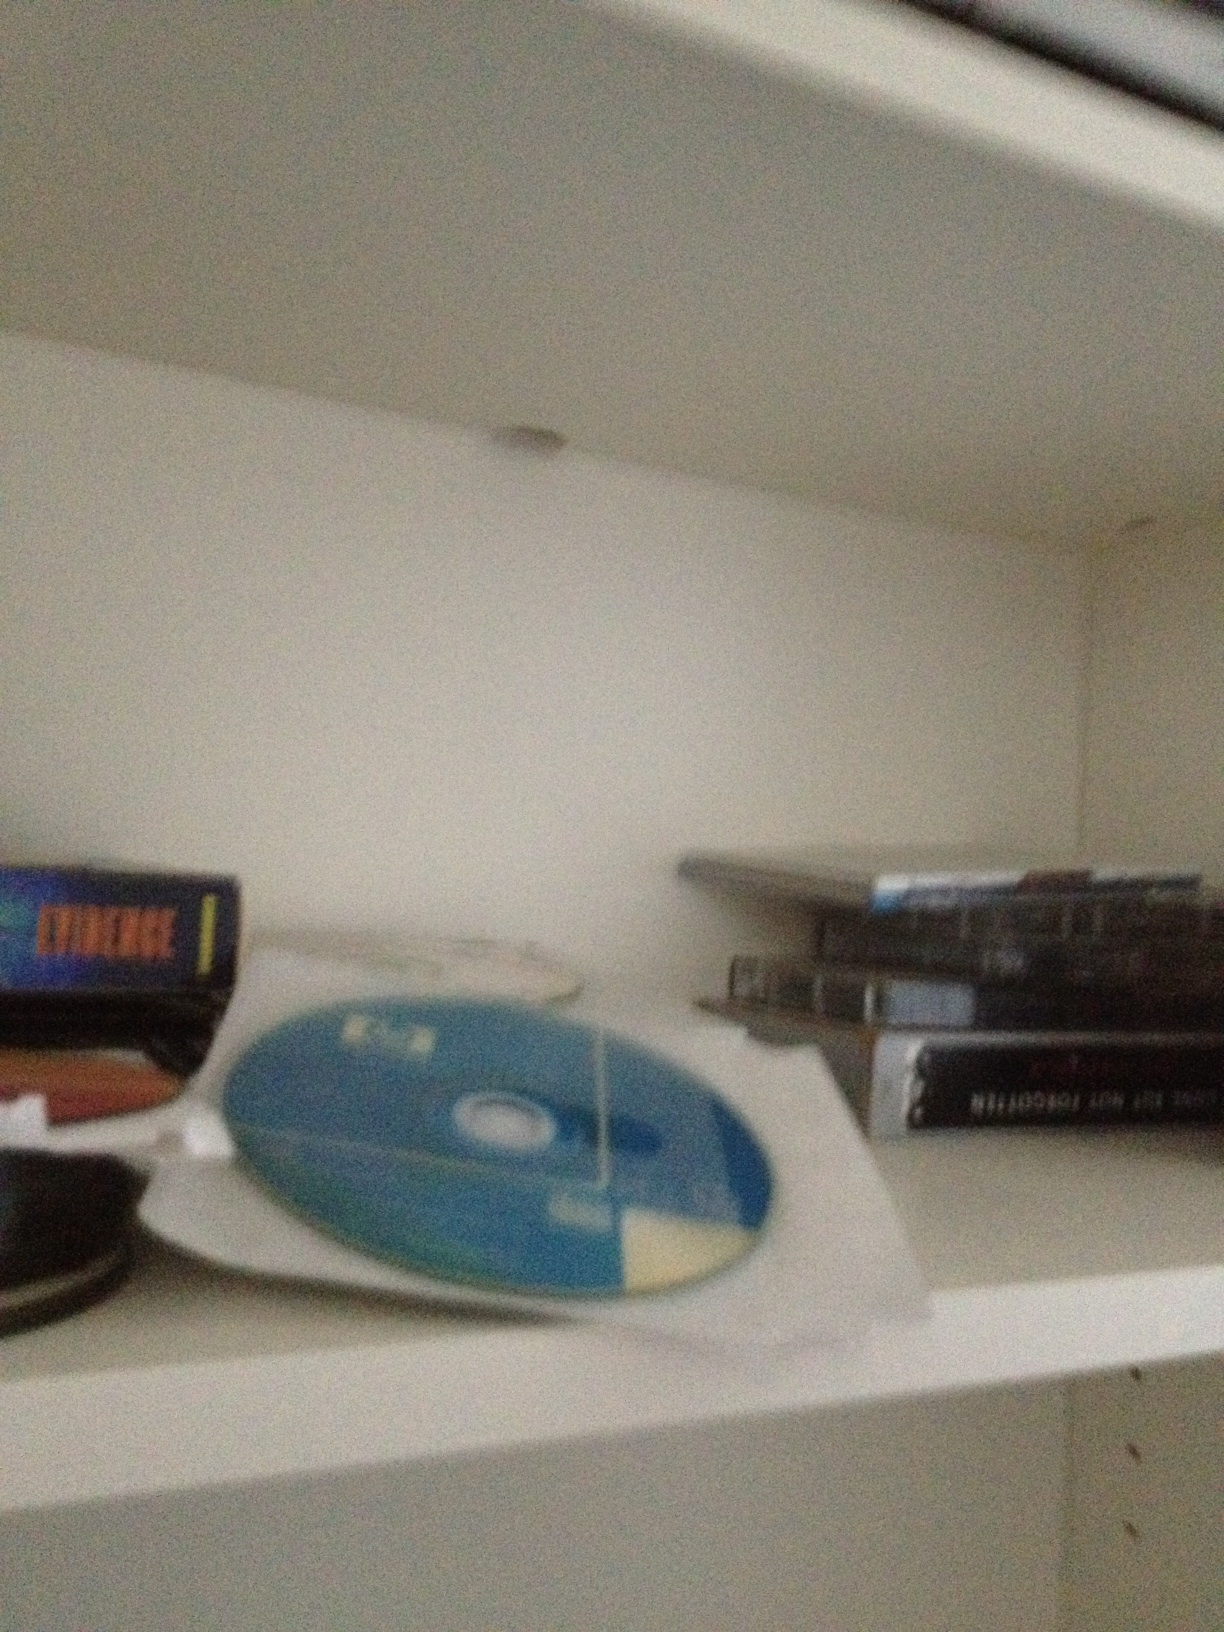Let's create a realistic scenario: why might someone keep so many CDs and DVDs on a shelf in today's digital age? Despite the prevalence of digital media, many people continue to cherish physical CDs and DVDs for various reasons. Some collectors appreciate the tangible nature of these items, enjoying the artwork, liner notes, and the satisfaction of owning a physical collection. Others might keep CDs and DVDs for specific media that are not available online, such as rare recordings, older software, or personal backups of their digital content. There's also a nostalgic aspect, as these discs can evoke memories of earlier times when they were the primary means of consuming media. 